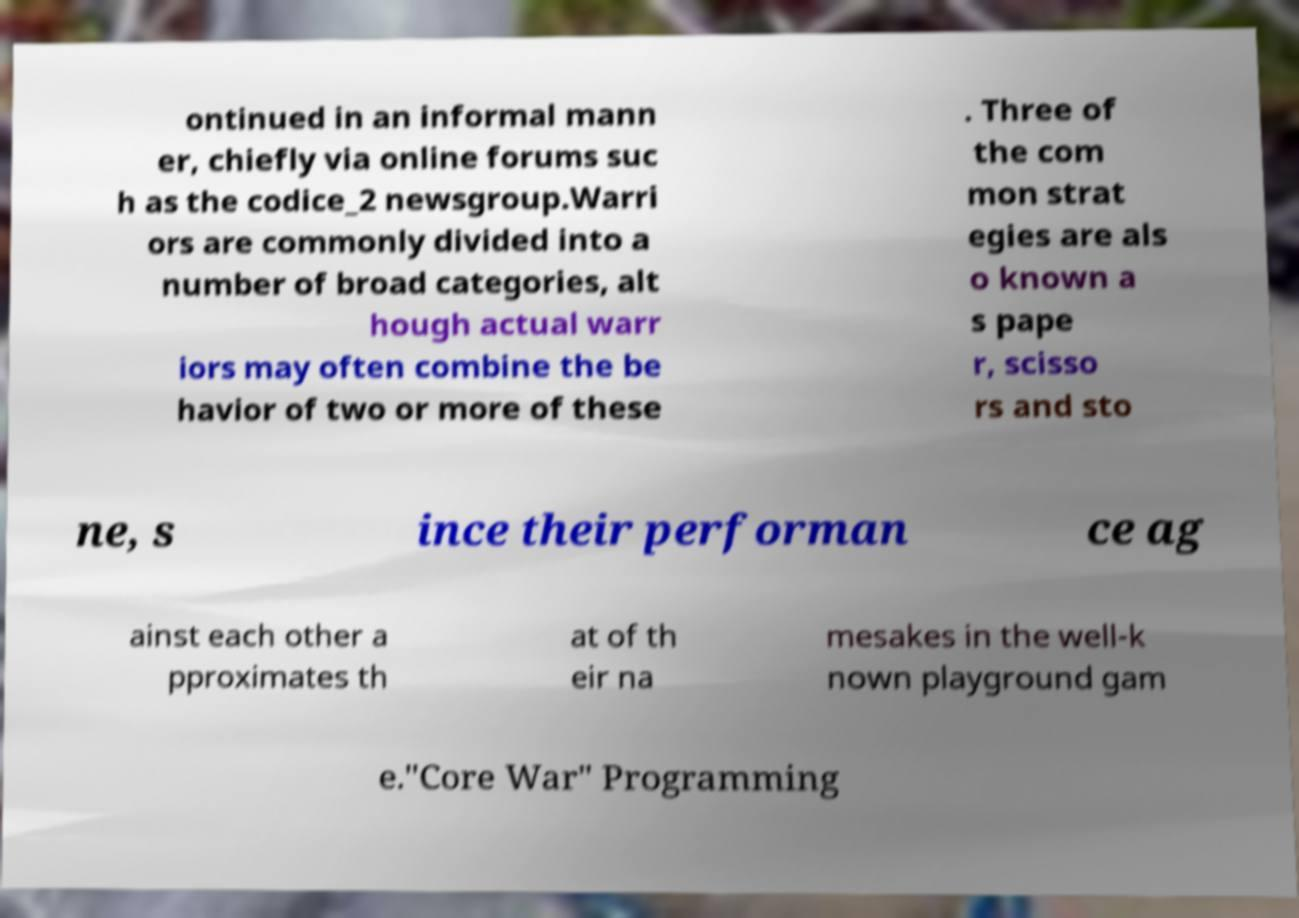Please read and relay the text visible in this image. What does it say? ontinued in an informal mann er, chiefly via online forums suc h as the codice_2 newsgroup.Warri ors are commonly divided into a number of broad categories, alt hough actual warr iors may often combine the be havior of two or more of these . Three of the com mon strat egies are als o known a s pape r, scisso rs and sto ne, s ince their performan ce ag ainst each other a pproximates th at of th eir na mesakes in the well-k nown playground gam e."Core War" Programming 